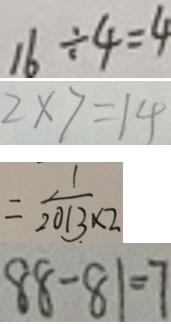Convert formula to latex. <formula><loc_0><loc_0><loc_500><loc_500>1 6 \div 4 = 4 
 2 \times 7 = 1 4 
 = \frac { 1 } { 2 0 1 3 \times 2 } 
 8 8 - 8 1 = 7</formula> 